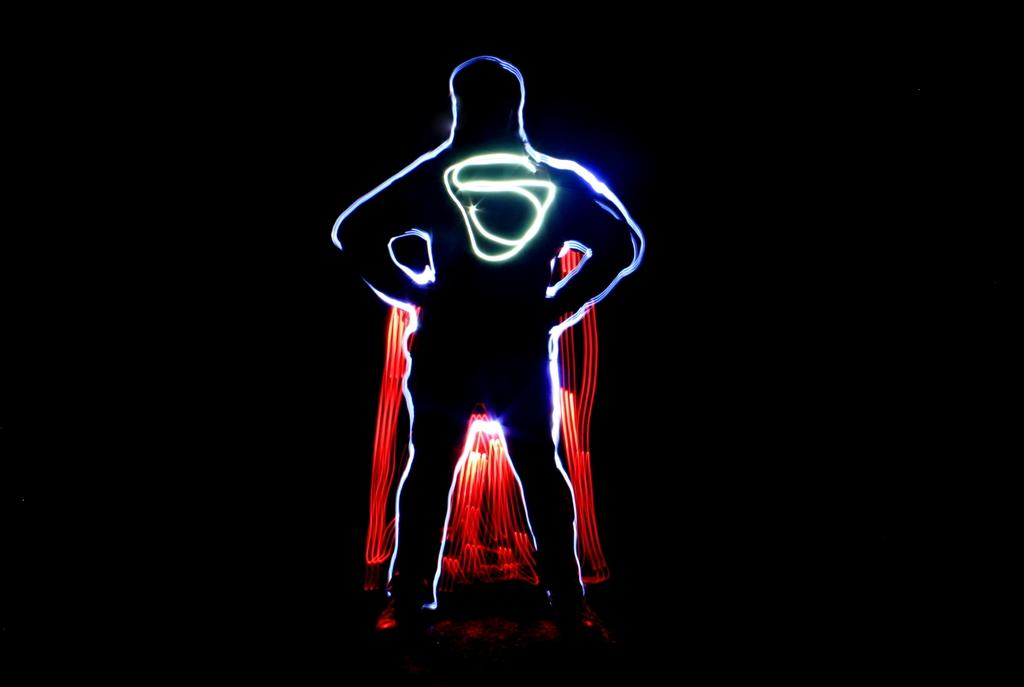What is the main subject of the image? The main subject of the image is a shadow of a person in the center of the image. What else is present in the image along with the shadow? The shadow is accompanied by lights. Can you describe the background of the image? The background of the image is dark. What type of holiday is being celebrated in the image? There is no indication of a holiday being celebrated in the image. What point is being made by the shadow in the image? The shadow in the image is not making a point; it is simply represents the presence of a person. 